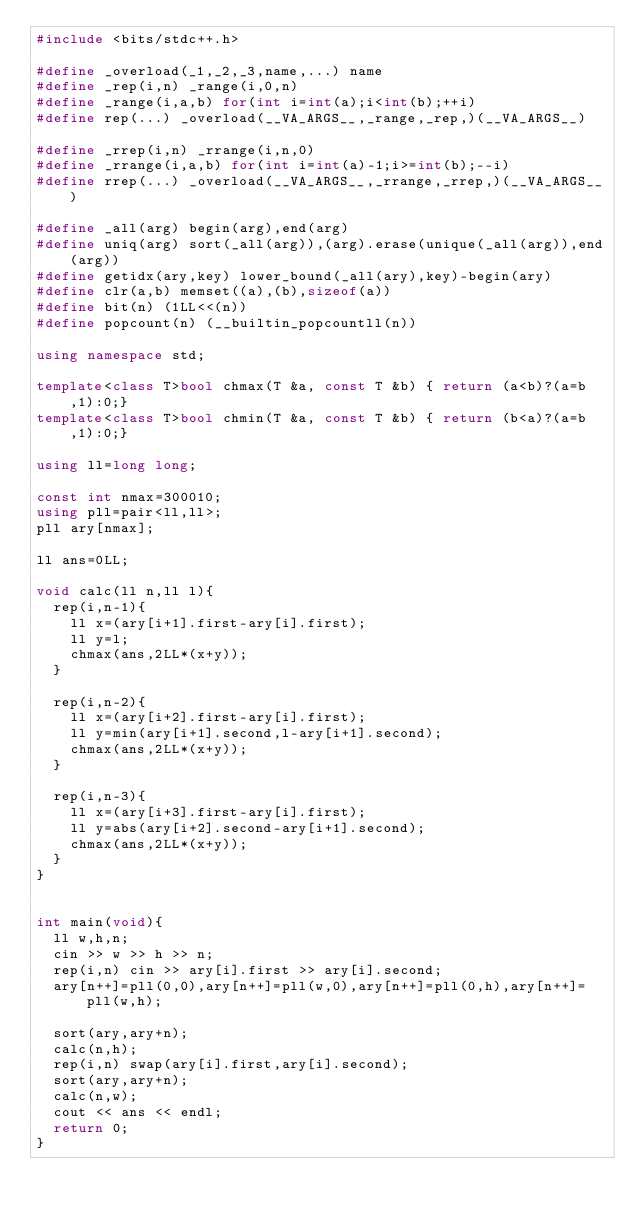<code> <loc_0><loc_0><loc_500><loc_500><_C++_>#include <bits/stdc++.h>

#define _overload(_1,_2,_3,name,...) name
#define _rep(i,n) _range(i,0,n)
#define _range(i,a,b) for(int i=int(a);i<int(b);++i)
#define rep(...) _overload(__VA_ARGS__,_range,_rep,)(__VA_ARGS__)

#define _rrep(i,n) _rrange(i,n,0)
#define _rrange(i,a,b) for(int i=int(a)-1;i>=int(b);--i)
#define rrep(...) _overload(__VA_ARGS__,_rrange,_rrep,)(__VA_ARGS__)

#define _all(arg) begin(arg),end(arg)
#define uniq(arg) sort(_all(arg)),(arg).erase(unique(_all(arg)),end(arg))
#define getidx(ary,key) lower_bound(_all(ary),key)-begin(ary)
#define clr(a,b) memset((a),(b),sizeof(a))
#define bit(n) (1LL<<(n))
#define popcount(n) (__builtin_popcountll(n))

using namespace std;

template<class T>bool chmax(T &a, const T &b) { return (a<b)?(a=b,1):0;}
template<class T>bool chmin(T &a, const T &b) { return (b<a)?(a=b,1):0;}

using ll=long long;

const int nmax=300010;
using pll=pair<ll,ll>;
pll ary[nmax];

ll ans=0LL;

void calc(ll n,ll l){
	rep(i,n-1){
		ll x=(ary[i+1].first-ary[i].first);
		ll y=l;
		chmax(ans,2LL*(x+y));
	}

	rep(i,n-2){
		ll x=(ary[i+2].first-ary[i].first);
		ll y=min(ary[i+1].second,l-ary[i+1].second);
		chmax(ans,2LL*(x+y));
	}

	rep(i,n-3){
		ll x=(ary[i+3].first-ary[i].first);
		ll y=abs(ary[i+2].second-ary[i+1].second);
		chmax(ans,2LL*(x+y));
	}
}


int main(void){
	ll w,h,n;
	cin >> w >> h >> n;
	rep(i,n) cin >> ary[i].first >> ary[i].second;
	ary[n++]=pll(0,0),ary[n++]=pll(w,0),ary[n++]=pll(0,h),ary[n++]=pll(w,h);
	
	sort(ary,ary+n);
	calc(n,h);
	rep(i,n) swap(ary[i].first,ary[i].second);
	sort(ary,ary+n);
	calc(n,w);
	cout << ans << endl;
	return 0;
}</code> 